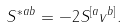Convert formula to latex. <formula><loc_0><loc_0><loc_500><loc_500>S ^ { * a b } = - 2 S ^ { [ a } v ^ { b ] } .</formula> 